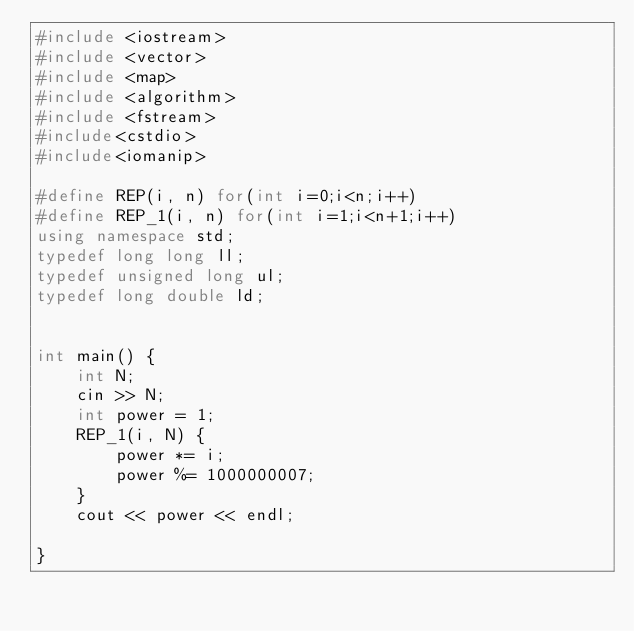Convert code to text. <code><loc_0><loc_0><loc_500><loc_500><_C++_>#include <iostream>
#include <vector>
#include <map>
#include <algorithm>
#include <fstream>
#include<cstdio>
#include<iomanip>

#define REP(i, n) for(int i=0;i<n;i++)
#define REP_1(i, n) for(int i=1;i<n+1;i++)
using namespace std;
typedef long long ll;
typedef unsigned long ul;
typedef long double ld;


int main() {
    int N;
    cin >> N;
    int power = 1;
    REP_1(i, N) {
        power *= i;
        power %= 1000000007;
    }
    cout << power << endl;

}</code> 